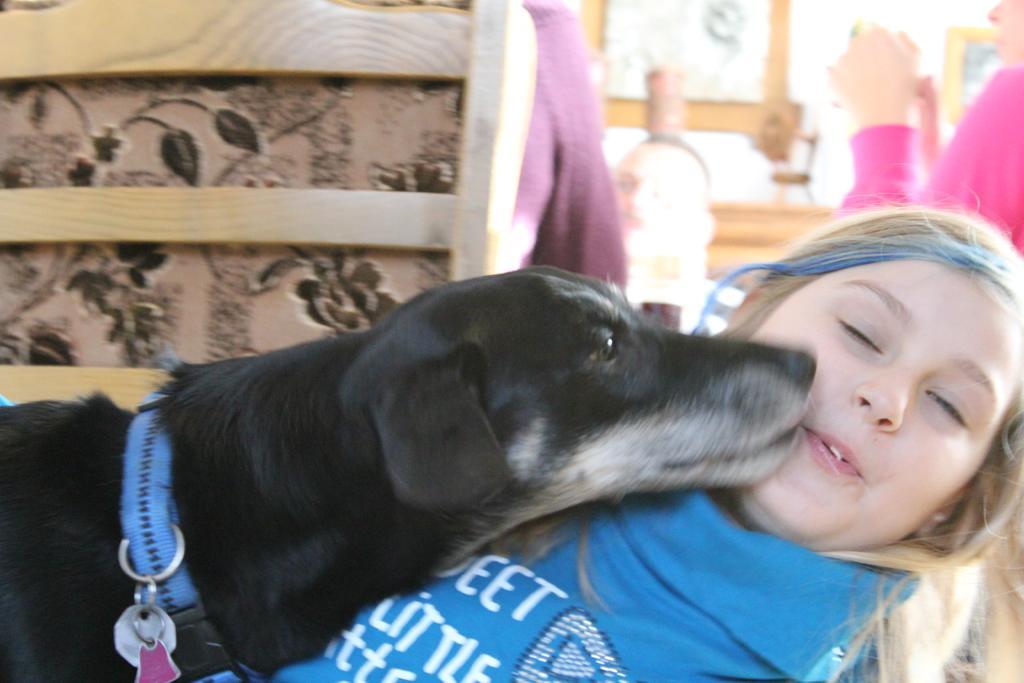Please provide a concise description of this image. In this image there is a girl in the foreground on which there is a dog. At the background there are people who are sitting in the chair. 